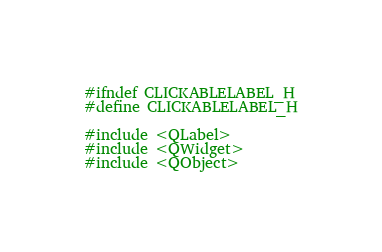<code> <loc_0><loc_0><loc_500><loc_500><_C++_>#ifndef CLICKABLELABEL_H
#define CLICKABLELABEL_H

#include <QLabel>
#include <QWidget>
#include <QObject>
</code> 